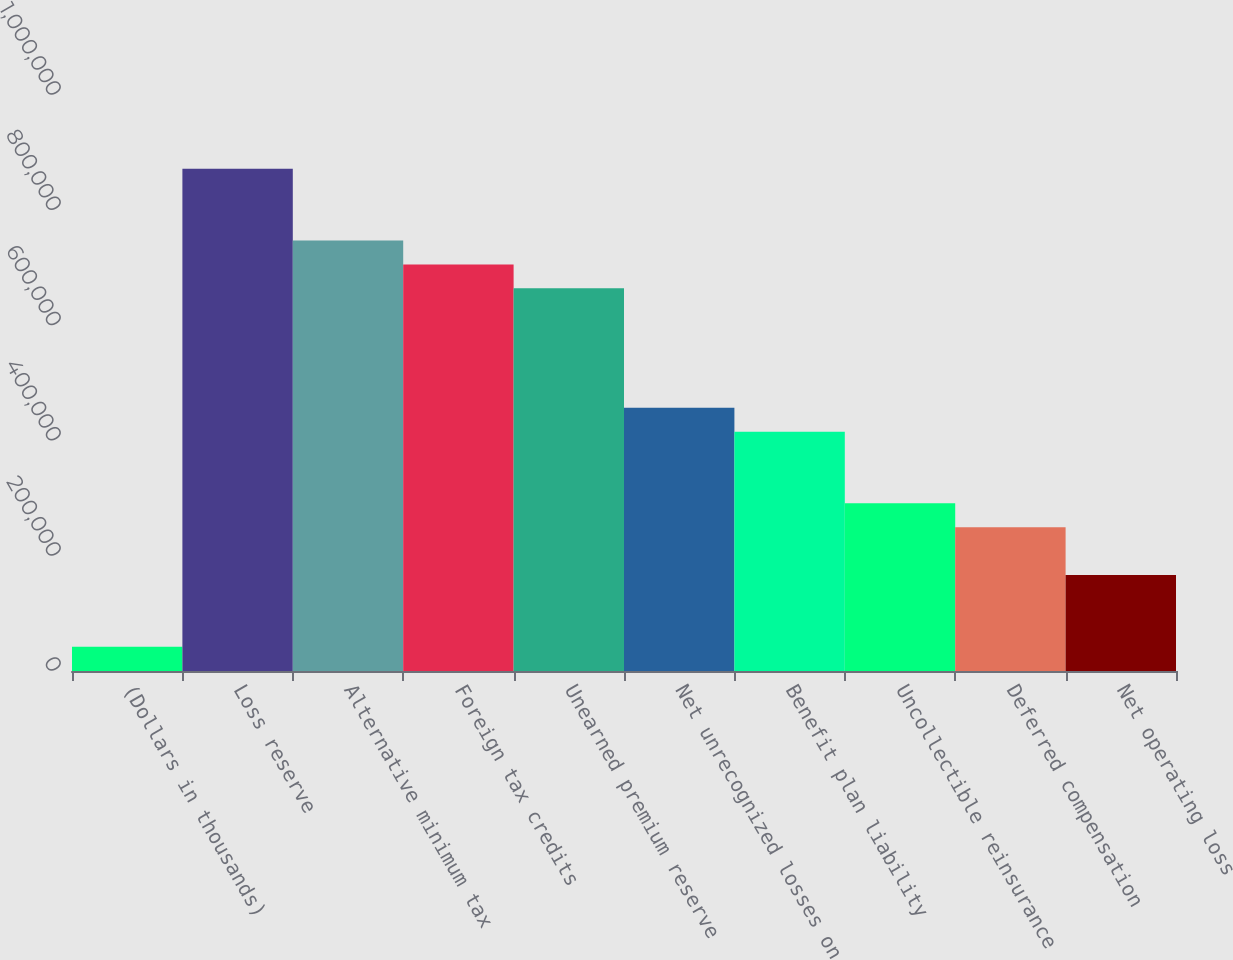Convert chart. <chart><loc_0><loc_0><loc_500><loc_500><bar_chart><fcel>(Dollars in thousands)<fcel>Loss reserve<fcel>Alternative minimum tax<fcel>Foreign tax credits<fcel>Unearned premium reserve<fcel>Net unrecognized losses on<fcel>Benefit plan liability<fcel>Uncollectible reinsurance<fcel>Deferred compensation<fcel>Net operating loss<nl><fcel>42095.8<fcel>871832<fcel>747371<fcel>705885<fcel>664398<fcel>456964<fcel>415477<fcel>291017<fcel>249530<fcel>166556<nl></chart> 